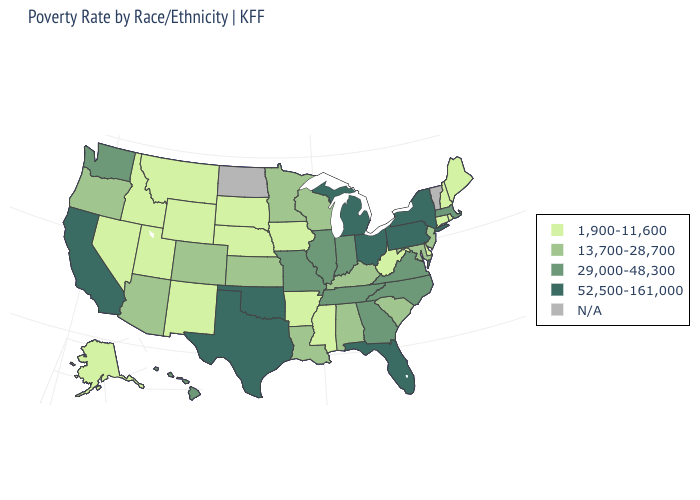Does Michigan have the highest value in the MidWest?
Short answer required. Yes. What is the lowest value in states that border Virginia?
Short answer required. 1,900-11,600. Name the states that have a value in the range 52,500-161,000?
Be succinct. California, Florida, Michigan, New York, Ohio, Oklahoma, Pennsylvania, Texas. Does Connecticut have the lowest value in the Northeast?
Keep it brief. Yes. What is the highest value in the USA?
Quick response, please. 52,500-161,000. Which states have the lowest value in the USA?
Give a very brief answer. Alaska, Arkansas, Connecticut, Delaware, Idaho, Iowa, Maine, Mississippi, Montana, Nebraska, Nevada, New Hampshire, New Mexico, Rhode Island, South Dakota, Utah, West Virginia, Wyoming. Does the map have missing data?
Concise answer only. Yes. What is the highest value in the USA?
Write a very short answer. 52,500-161,000. What is the value of Missouri?
Be succinct. 29,000-48,300. Name the states that have a value in the range 1,900-11,600?
Answer briefly. Alaska, Arkansas, Connecticut, Delaware, Idaho, Iowa, Maine, Mississippi, Montana, Nebraska, Nevada, New Hampshire, New Mexico, Rhode Island, South Dakota, Utah, West Virginia, Wyoming. What is the value of Oregon?
Give a very brief answer. 13,700-28,700. Name the states that have a value in the range 13,700-28,700?
Concise answer only. Alabama, Arizona, Colorado, Kansas, Kentucky, Louisiana, Maryland, Minnesota, New Jersey, Oregon, South Carolina, Wisconsin. Does West Virginia have the highest value in the USA?
Write a very short answer. No. What is the value of Illinois?
Answer briefly. 29,000-48,300. What is the value of Mississippi?
Quick response, please. 1,900-11,600. 